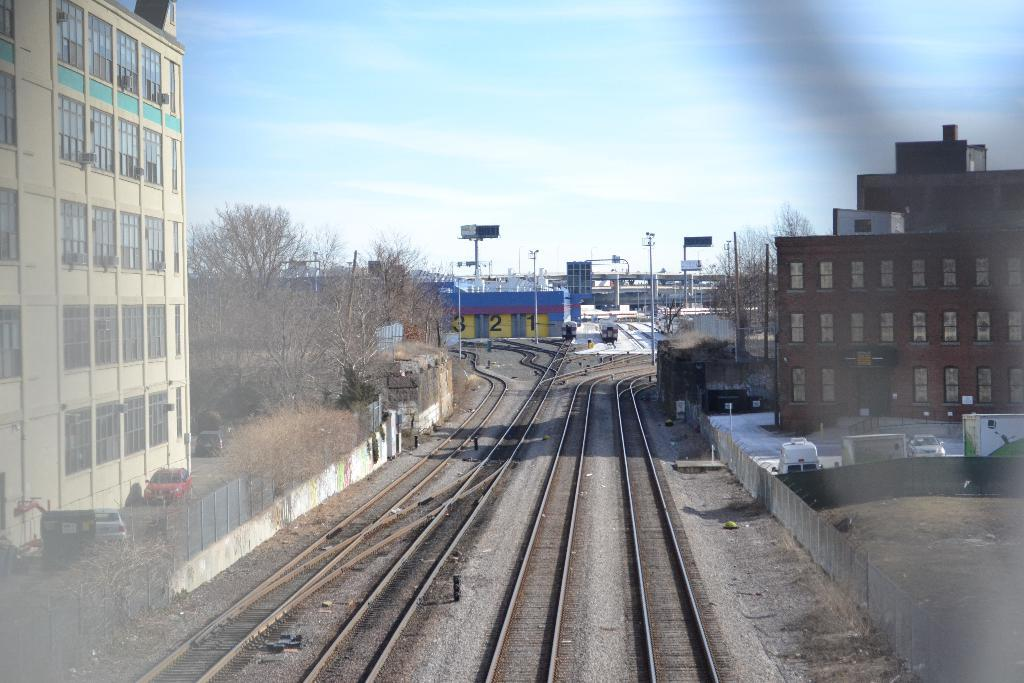What type of transportation infrastructure is present in the image? There is a railway track in the image. What can be seen traveling on the railway track? There are vehicles in the image. What type of barrier is present in the image? There is a fence in the image. What type of structures are visible in the image? There are buildings in the image. What type of natural elements are visible in the image? There are trees in the image. What is visible at the top of the image? The sky is visible at the top of the image. What type of curtain is hanging in the trees in the image? There is no curtain present in the image; it features a railway track, vehicles, a fence, buildings, trees, and the sky. What account can be seen being settled by the vehicles in the image? There is no account being settled in the image; it simply shows vehicles traveling on a railway track. 